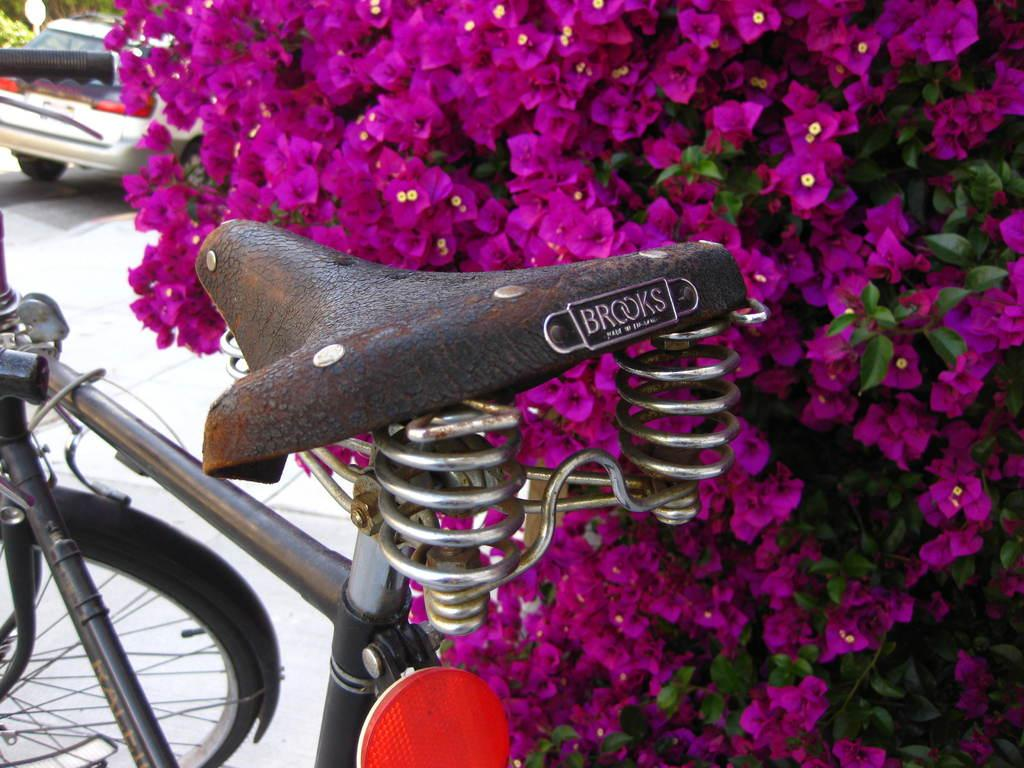What is the main mode of transportation in the image? There is a cycle in the image. What can be seen behind the cycle? There are pink flowers behind the cycle. What other vehicle is present in the image? There is a car on the left side of the image. How many books are stacked on the cycle in the image? There are no books present in the image; it features a cycle, pink flowers, and a car. 